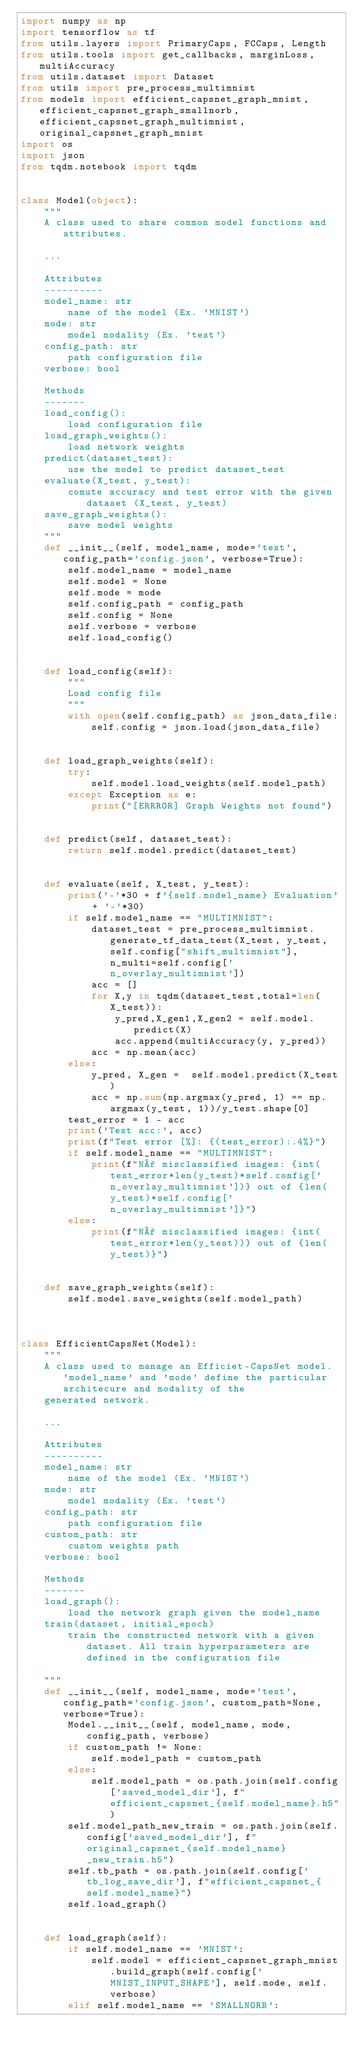<code> <loc_0><loc_0><loc_500><loc_500><_Python_>import numpy as np
import tensorflow as tf
from utils.layers import PrimaryCaps, FCCaps, Length
from utils.tools import get_callbacks, marginLoss, multiAccuracy
from utils.dataset import Dataset
from utils import pre_process_multimnist
from models import efficient_capsnet_graph_mnist, efficient_capsnet_graph_smallnorb, efficient_capsnet_graph_multimnist, original_capsnet_graph_mnist
import os
import json
from tqdm.notebook import tqdm


class Model(object):
    """
    A class used to share common model functions and attributes.
    
    ...
    
    Attributes
    ----------
    model_name: str
        name of the model (Ex. 'MNIST')
    mode: str
        model modality (Ex. 'test')
    config_path: str
        path configuration file
    verbose: bool
    
    Methods
    -------
    load_config():
        load configuration file
    load_graph_weights():
        load network weights
    predict(dataset_test):
        use the model to predict dataset_test
    evaluate(X_test, y_test):
        comute accuracy and test error with the given dataset (X_test, y_test)
    save_graph_weights():
        save model weights
    """
    def __init__(self, model_name, mode='test', config_path='config.json', verbose=True):
        self.model_name = model_name
        self.model = None
        self.mode = mode
        self.config_path = config_path
        self.config = None
        self.verbose = verbose
        self.load_config()


    def load_config(self):
        """
        Load config file
        """
        with open(self.config_path) as json_data_file:
            self.config = json.load(json_data_file)
    

    def load_graph_weights(self):
        try:
            self.model.load_weights(self.model_path)
        except Exception as e:
            print("[ERRROR] Graph Weights not found")
            
        
    def predict(self, dataset_test):
        return self.model.predict(dataset_test)
    

    def evaluate(self, X_test, y_test):
        print('-'*30 + f'{self.model_name} Evaluation' + '-'*30)
        if self.model_name == "MULTIMNIST":
            dataset_test = pre_process_multimnist.generate_tf_data_test(X_test, y_test, self.config["shift_multimnist"], n_multi=self.config['n_overlay_multimnist'])
            acc = []
            for X,y in tqdm(dataset_test,total=len(X_test)):
                y_pred,X_gen1,X_gen2 = self.model.predict(X)
                acc.append(multiAccuracy(y, y_pred))
            acc = np.mean(acc)
        else:
            y_pred, X_gen =  self.model.predict(X_test)
            acc = np.sum(np.argmax(y_pred, 1) == np.argmax(y_test, 1))/y_test.shape[0]
        test_error = 1 - acc
        print('Test acc:', acc)
        print(f"Test error [%]: {(test_error):.4%}")
        if self.model_name == "MULTIMNIST":
            print(f"N° misclassified images: {int(test_error*len(y_test)*self.config['n_overlay_multimnist'])} out of {len(y_test)*self.config['n_overlay_multimnist']}")
        else:
            print(f"N° misclassified images: {int(test_error*len(y_test))} out of {len(y_test)}")


    def save_graph_weights(self):
        self.model.save_weights(self.model_path)



class EfficientCapsNet(Model):
    """
    A class used to manage an Efficiet-CapsNet model. 'model_name' and 'mode' define the particular architecure and modality of the 
    generated network.
    
    ...
    
    Attributes
    ----------
    model_name: str
        name of the model (Ex. 'MNIST')
    mode: str
        model modality (Ex. 'test')
    config_path: str
        path configuration file
    custom_path: str
        custom weights path
    verbose: bool
    
    Methods
    -------
    load_graph():
        load the network graph given the model_name
    train(dataset, initial_epoch)
        train the constructed network with a given dataset. All train hyperparameters are defined in the configuration file

    """
    def __init__(self, model_name, mode='test', config_path='config.json', custom_path=None, verbose=True):
        Model.__init__(self, model_name, mode, config_path, verbose)
        if custom_path != None:
            self.model_path = custom_path
        else:
            self.model_path = os.path.join(self.config['saved_model_dir'], f"efficient_capsnet_{self.model_name}.h5")
        self.model_path_new_train = os.path.join(self.config['saved_model_dir'], f"original_capsnet_{self.model_name}_new_train.h5")
        self.tb_path = os.path.join(self.config['tb_log_save_dir'], f"efficient_capsnet_{self.model_name}")
        self.load_graph()
    

    def load_graph(self):
        if self.model_name == 'MNIST':
            self.model = efficient_capsnet_graph_mnist.build_graph(self.config['MNIST_INPUT_SHAPE'], self.mode, self.verbose)
        elif self.model_name == 'SMALLNORB':</code> 